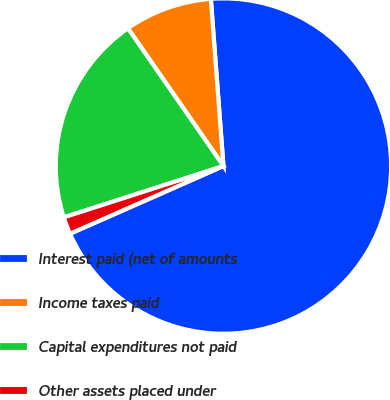Convert chart. <chart><loc_0><loc_0><loc_500><loc_500><pie_chart><fcel>Interest paid (net of amounts<fcel>Income taxes paid<fcel>Capital expenditures not paid<fcel>Other assets placed under<nl><fcel>69.58%<fcel>8.45%<fcel>20.3%<fcel>1.66%<nl></chart> 